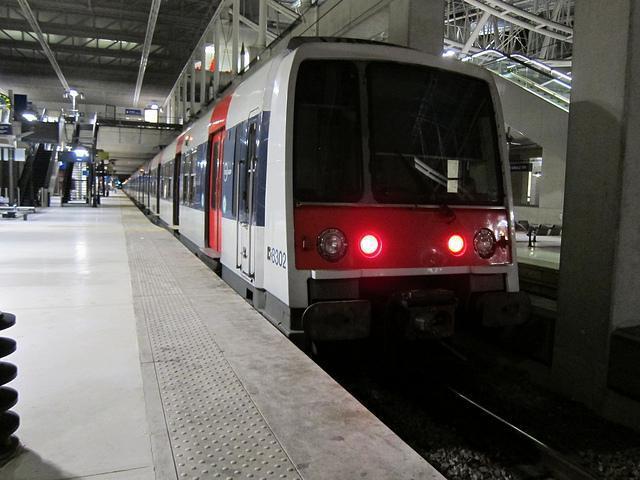How many lights are lit on the front of the train?
Give a very brief answer. 2. How many red lights are there?
Give a very brief answer. 2. How many trains are in the picture?
Give a very brief answer. 1. How many people have ties on?
Give a very brief answer. 0. 